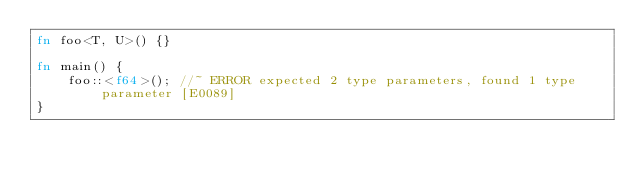<code> <loc_0><loc_0><loc_500><loc_500><_Rust_>fn foo<T, U>() {}

fn main() {
    foo::<f64>(); //~ ERROR expected 2 type parameters, found 1 type parameter [E0089]
}
</code> 